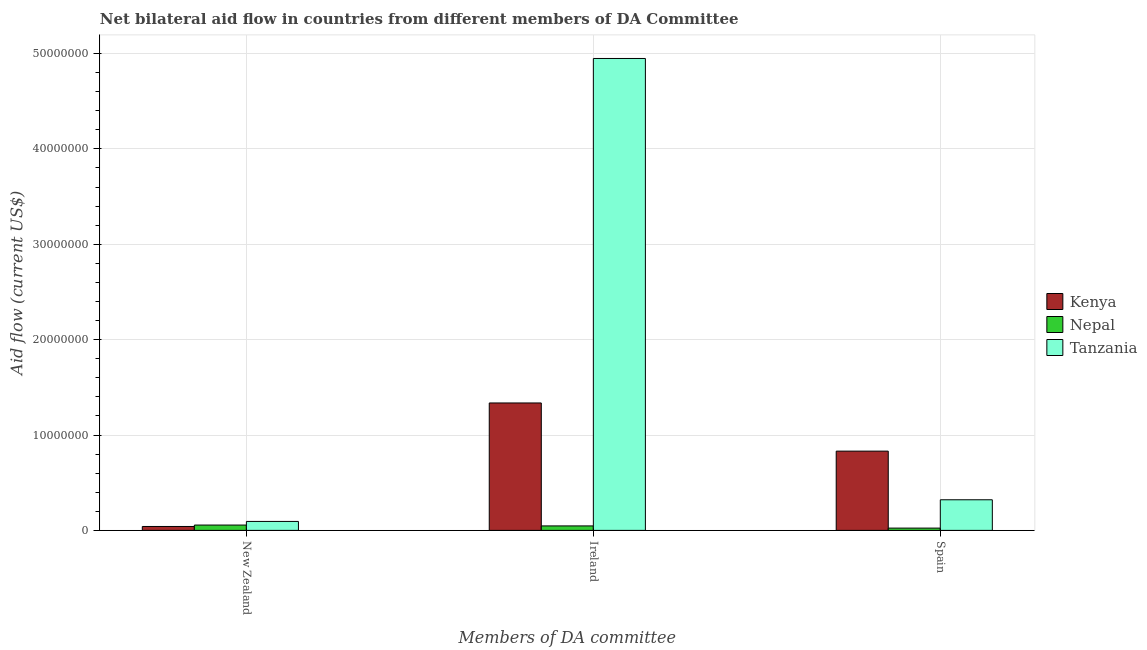Are the number of bars per tick equal to the number of legend labels?
Your response must be concise. Yes. Are the number of bars on each tick of the X-axis equal?
Your answer should be very brief. Yes. How many bars are there on the 1st tick from the right?
Provide a short and direct response. 3. What is the label of the 1st group of bars from the left?
Your response must be concise. New Zealand. What is the amount of aid provided by new zealand in Tanzania?
Ensure brevity in your answer.  9.40e+05. Across all countries, what is the maximum amount of aid provided by ireland?
Your answer should be compact. 4.95e+07. Across all countries, what is the minimum amount of aid provided by ireland?
Offer a terse response. 4.70e+05. In which country was the amount of aid provided by new zealand maximum?
Your response must be concise. Tanzania. In which country was the amount of aid provided by spain minimum?
Your answer should be very brief. Nepal. What is the total amount of aid provided by ireland in the graph?
Your response must be concise. 6.33e+07. What is the difference between the amount of aid provided by new zealand in Tanzania and that in Kenya?
Provide a succinct answer. 5.30e+05. What is the difference between the amount of aid provided by ireland in Tanzania and the amount of aid provided by spain in Kenya?
Your response must be concise. 4.12e+07. What is the average amount of aid provided by new zealand per country?
Your answer should be very brief. 6.37e+05. What is the difference between the amount of aid provided by spain and amount of aid provided by new zealand in Kenya?
Your answer should be very brief. 7.90e+06. In how many countries, is the amount of aid provided by new zealand greater than 12000000 US$?
Your answer should be very brief. 0. What is the ratio of the amount of aid provided by ireland in Nepal to that in Kenya?
Make the answer very short. 0.04. What is the difference between the highest and the lowest amount of aid provided by new zealand?
Provide a short and direct response. 5.30e+05. In how many countries, is the amount of aid provided by new zealand greater than the average amount of aid provided by new zealand taken over all countries?
Your answer should be compact. 1. What does the 3rd bar from the left in New Zealand represents?
Your response must be concise. Tanzania. What does the 1st bar from the right in Ireland represents?
Ensure brevity in your answer.  Tanzania. Is it the case that in every country, the sum of the amount of aid provided by new zealand and amount of aid provided by ireland is greater than the amount of aid provided by spain?
Ensure brevity in your answer.  Yes. How many bars are there?
Offer a very short reply. 9. How many countries are there in the graph?
Ensure brevity in your answer.  3. What is the difference between two consecutive major ticks on the Y-axis?
Provide a succinct answer. 1.00e+07. Does the graph contain any zero values?
Your answer should be very brief. No. Does the graph contain grids?
Your response must be concise. Yes. Where does the legend appear in the graph?
Keep it short and to the point. Center right. What is the title of the graph?
Your response must be concise. Net bilateral aid flow in countries from different members of DA Committee. Does "Azerbaijan" appear as one of the legend labels in the graph?
Give a very brief answer. No. What is the label or title of the X-axis?
Your answer should be very brief. Members of DA committee. What is the label or title of the Y-axis?
Your answer should be very brief. Aid flow (current US$). What is the Aid flow (current US$) in Kenya in New Zealand?
Make the answer very short. 4.10e+05. What is the Aid flow (current US$) in Nepal in New Zealand?
Keep it short and to the point. 5.60e+05. What is the Aid flow (current US$) in Tanzania in New Zealand?
Your answer should be compact. 9.40e+05. What is the Aid flow (current US$) in Kenya in Ireland?
Your answer should be very brief. 1.34e+07. What is the Aid flow (current US$) of Tanzania in Ireland?
Offer a very short reply. 4.95e+07. What is the Aid flow (current US$) in Kenya in Spain?
Give a very brief answer. 8.31e+06. What is the Aid flow (current US$) in Nepal in Spain?
Ensure brevity in your answer.  2.40e+05. What is the Aid flow (current US$) of Tanzania in Spain?
Your answer should be compact. 3.21e+06. Across all Members of DA committee, what is the maximum Aid flow (current US$) of Kenya?
Offer a terse response. 1.34e+07. Across all Members of DA committee, what is the maximum Aid flow (current US$) of Nepal?
Keep it short and to the point. 5.60e+05. Across all Members of DA committee, what is the maximum Aid flow (current US$) in Tanzania?
Ensure brevity in your answer.  4.95e+07. Across all Members of DA committee, what is the minimum Aid flow (current US$) of Kenya?
Offer a terse response. 4.10e+05. Across all Members of DA committee, what is the minimum Aid flow (current US$) of Nepal?
Offer a very short reply. 2.40e+05. Across all Members of DA committee, what is the minimum Aid flow (current US$) of Tanzania?
Keep it short and to the point. 9.40e+05. What is the total Aid flow (current US$) in Kenya in the graph?
Make the answer very short. 2.21e+07. What is the total Aid flow (current US$) in Nepal in the graph?
Your response must be concise. 1.27e+06. What is the total Aid flow (current US$) of Tanzania in the graph?
Offer a very short reply. 5.36e+07. What is the difference between the Aid flow (current US$) in Kenya in New Zealand and that in Ireland?
Provide a succinct answer. -1.30e+07. What is the difference between the Aid flow (current US$) in Nepal in New Zealand and that in Ireland?
Give a very brief answer. 9.00e+04. What is the difference between the Aid flow (current US$) in Tanzania in New Zealand and that in Ireland?
Give a very brief answer. -4.85e+07. What is the difference between the Aid flow (current US$) of Kenya in New Zealand and that in Spain?
Your answer should be very brief. -7.90e+06. What is the difference between the Aid flow (current US$) in Tanzania in New Zealand and that in Spain?
Your answer should be compact. -2.27e+06. What is the difference between the Aid flow (current US$) in Kenya in Ireland and that in Spain?
Ensure brevity in your answer.  5.05e+06. What is the difference between the Aid flow (current US$) in Tanzania in Ireland and that in Spain?
Keep it short and to the point. 4.63e+07. What is the difference between the Aid flow (current US$) in Kenya in New Zealand and the Aid flow (current US$) in Nepal in Ireland?
Ensure brevity in your answer.  -6.00e+04. What is the difference between the Aid flow (current US$) of Kenya in New Zealand and the Aid flow (current US$) of Tanzania in Ireland?
Your answer should be compact. -4.91e+07. What is the difference between the Aid flow (current US$) of Nepal in New Zealand and the Aid flow (current US$) of Tanzania in Ireland?
Your answer should be very brief. -4.89e+07. What is the difference between the Aid flow (current US$) of Kenya in New Zealand and the Aid flow (current US$) of Nepal in Spain?
Provide a short and direct response. 1.70e+05. What is the difference between the Aid flow (current US$) of Kenya in New Zealand and the Aid flow (current US$) of Tanzania in Spain?
Give a very brief answer. -2.80e+06. What is the difference between the Aid flow (current US$) in Nepal in New Zealand and the Aid flow (current US$) in Tanzania in Spain?
Your answer should be compact. -2.65e+06. What is the difference between the Aid flow (current US$) in Kenya in Ireland and the Aid flow (current US$) in Nepal in Spain?
Provide a short and direct response. 1.31e+07. What is the difference between the Aid flow (current US$) in Kenya in Ireland and the Aid flow (current US$) in Tanzania in Spain?
Your response must be concise. 1.02e+07. What is the difference between the Aid flow (current US$) in Nepal in Ireland and the Aid flow (current US$) in Tanzania in Spain?
Provide a succinct answer. -2.74e+06. What is the average Aid flow (current US$) in Kenya per Members of DA committee?
Offer a terse response. 7.36e+06. What is the average Aid flow (current US$) of Nepal per Members of DA committee?
Offer a terse response. 4.23e+05. What is the average Aid flow (current US$) of Tanzania per Members of DA committee?
Make the answer very short. 1.79e+07. What is the difference between the Aid flow (current US$) of Kenya and Aid flow (current US$) of Nepal in New Zealand?
Keep it short and to the point. -1.50e+05. What is the difference between the Aid flow (current US$) in Kenya and Aid flow (current US$) in Tanzania in New Zealand?
Your response must be concise. -5.30e+05. What is the difference between the Aid flow (current US$) in Nepal and Aid flow (current US$) in Tanzania in New Zealand?
Give a very brief answer. -3.80e+05. What is the difference between the Aid flow (current US$) of Kenya and Aid flow (current US$) of Nepal in Ireland?
Provide a short and direct response. 1.29e+07. What is the difference between the Aid flow (current US$) of Kenya and Aid flow (current US$) of Tanzania in Ireland?
Ensure brevity in your answer.  -3.61e+07. What is the difference between the Aid flow (current US$) in Nepal and Aid flow (current US$) in Tanzania in Ireland?
Offer a terse response. -4.90e+07. What is the difference between the Aid flow (current US$) in Kenya and Aid flow (current US$) in Nepal in Spain?
Keep it short and to the point. 8.07e+06. What is the difference between the Aid flow (current US$) of Kenya and Aid flow (current US$) of Tanzania in Spain?
Offer a terse response. 5.10e+06. What is the difference between the Aid flow (current US$) in Nepal and Aid flow (current US$) in Tanzania in Spain?
Provide a succinct answer. -2.97e+06. What is the ratio of the Aid flow (current US$) in Kenya in New Zealand to that in Ireland?
Give a very brief answer. 0.03. What is the ratio of the Aid flow (current US$) of Nepal in New Zealand to that in Ireland?
Ensure brevity in your answer.  1.19. What is the ratio of the Aid flow (current US$) of Tanzania in New Zealand to that in Ireland?
Offer a terse response. 0.02. What is the ratio of the Aid flow (current US$) of Kenya in New Zealand to that in Spain?
Offer a very short reply. 0.05. What is the ratio of the Aid flow (current US$) in Nepal in New Zealand to that in Spain?
Your answer should be very brief. 2.33. What is the ratio of the Aid flow (current US$) of Tanzania in New Zealand to that in Spain?
Offer a terse response. 0.29. What is the ratio of the Aid flow (current US$) in Kenya in Ireland to that in Spain?
Offer a terse response. 1.61. What is the ratio of the Aid flow (current US$) of Nepal in Ireland to that in Spain?
Provide a short and direct response. 1.96. What is the ratio of the Aid flow (current US$) of Tanzania in Ireland to that in Spain?
Provide a succinct answer. 15.41. What is the difference between the highest and the second highest Aid flow (current US$) in Kenya?
Keep it short and to the point. 5.05e+06. What is the difference between the highest and the second highest Aid flow (current US$) of Nepal?
Your answer should be very brief. 9.00e+04. What is the difference between the highest and the second highest Aid flow (current US$) of Tanzania?
Your answer should be compact. 4.63e+07. What is the difference between the highest and the lowest Aid flow (current US$) of Kenya?
Give a very brief answer. 1.30e+07. What is the difference between the highest and the lowest Aid flow (current US$) of Nepal?
Ensure brevity in your answer.  3.20e+05. What is the difference between the highest and the lowest Aid flow (current US$) of Tanzania?
Your answer should be very brief. 4.85e+07. 